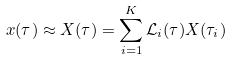<formula> <loc_0><loc_0><loc_500><loc_500>x ( \tau ) \approx X ( \tau ) = \sum _ { i = 1 } ^ { K } \mathcal { L } _ { i } ( \tau ) X ( \tau _ { i } )</formula> 